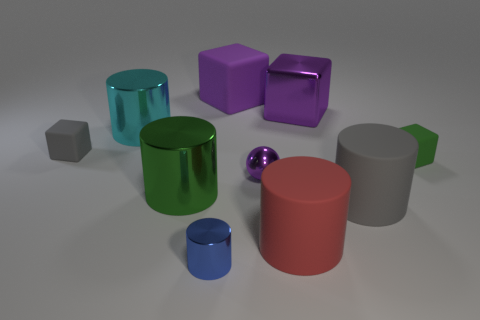Is there any object that stands out due to its size compared to the others? Yes, the large red cylinder stands out due to its size, being notably larger than the other objects in the image.  Can you tell the orientation of the light source from the shadows in the image? The orientation of the light source can be inferred from the angle and length of the shadows. They suggest that the light source is above the scene, slightly to the left. 